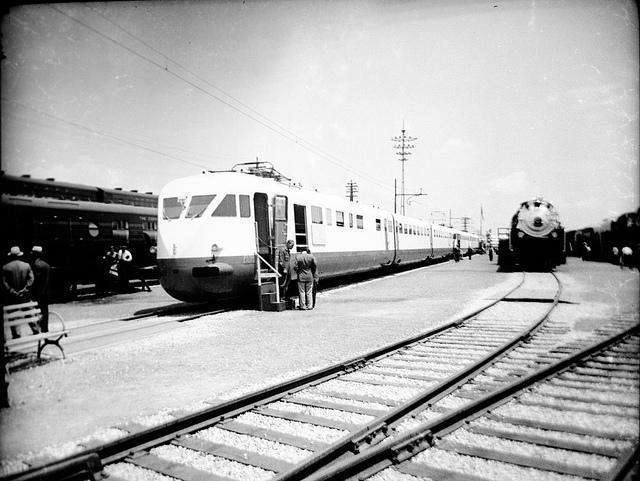How many tracks are displayed?
Give a very brief answer. 3. How many trains are there?
Give a very brief answer. 4. 